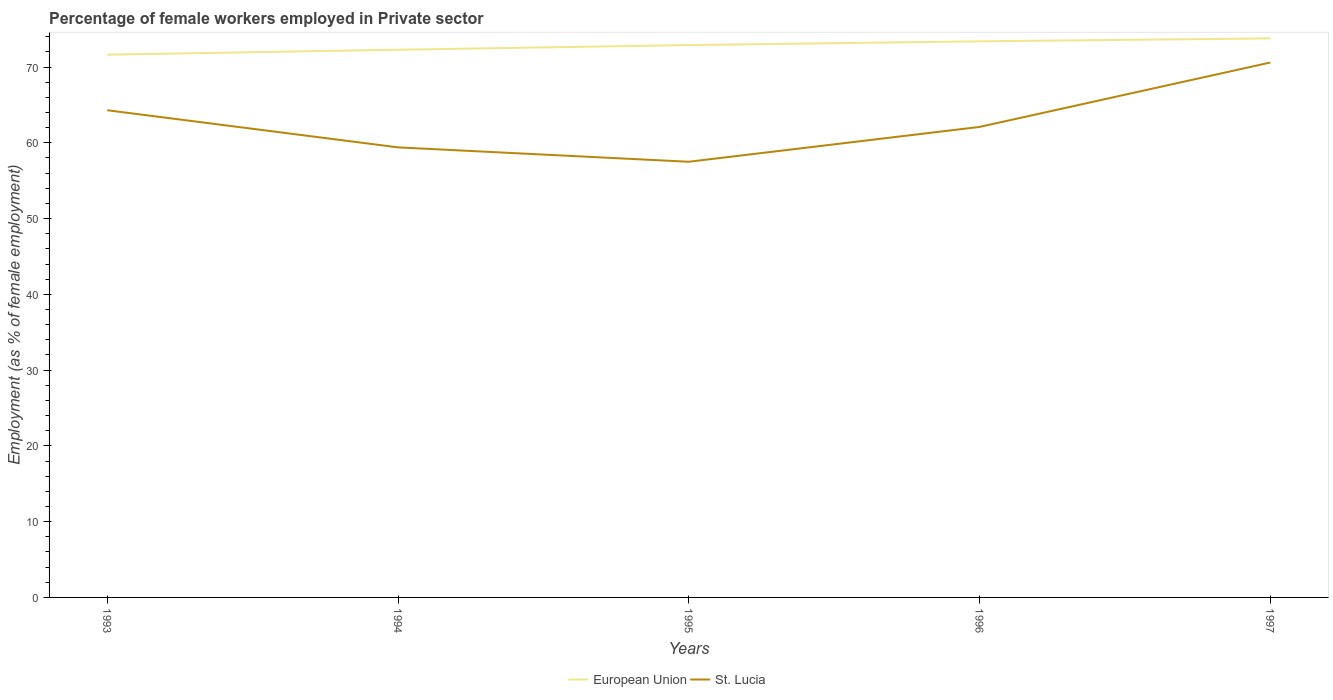Does the line corresponding to St. Lucia intersect with the line corresponding to European Union?
Your answer should be very brief. No. Is the number of lines equal to the number of legend labels?
Ensure brevity in your answer.  Yes. Across all years, what is the maximum percentage of females employed in Private sector in St. Lucia?
Offer a terse response. 57.5. In which year was the percentage of females employed in Private sector in St. Lucia maximum?
Offer a very short reply. 1995. What is the total percentage of females employed in Private sector in St. Lucia in the graph?
Ensure brevity in your answer.  -4.6. What is the difference between the highest and the second highest percentage of females employed in Private sector in St. Lucia?
Your response must be concise. 13.1. Is the percentage of females employed in Private sector in European Union strictly greater than the percentage of females employed in Private sector in St. Lucia over the years?
Provide a succinct answer. No. How many lines are there?
Ensure brevity in your answer.  2. How many years are there in the graph?
Provide a short and direct response. 5. Are the values on the major ticks of Y-axis written in scientific E-notation?
Your answer should be compact. No. Does the graph contain any zero values?
Provide a short and direct response. No. Where does the legend appear in the graph?
Provide a short and direct response. Bottom center. What is the title of the graph?
Give a very brief answer. Percentage of female workers employed in Private sector. Does "Fragile and conflict affected situations" appear as one of the legend labels in the graph?
Provide a succinct answer. No. What is the label or title of the Y-axis?
Give a very brief answer. Employment (as % of female employment). What is the Employment (as % of female employment) of European Union in 1993?
Provide a succinct answer. 71.63. What is the Employment (as % of female employment) in St. Lucia in 1993?
Give a very brief answer. 64.3. What is the Employment (as % of female employment) in European Union in 1994?
Make the answer very short. 72.29. What is the Employment (as % of female employment) of St. Lucia in 1994?
Make the answer very short. 59.4. What is the Employment (as % of female employment) of European Union in 1995?
Make the answer very short. 72.9. What is the Employment (as % of female employment) of St. Lucia in 1995?
Make the answer very short. 57.5. What is the Employment (as % of female employment) of European Union in 1996?
Keep it short and to the point. 73.4. What is the Employment (as % of female employment) of St. Lucia in 1996?
Offer a terse response. 62.1. What is the Employment (as % of female employment) of European Union in 1997?
Make the answer very short. 73.78. What is the Employment (as % of female employment) of St. Lucia in 1997?
Keep it short and to the point. 70.6. Across all years, what is the maximum Employment (as % of female employment) in European Union?
Ensure brevity in your answer.  73.78. Across all years, what is the maximum Employment (as % of female employment) in St. Lucia?
Keep it short and to the point. 70.6. Across all years, what is the minimum Employment (as % of female employment) in European Union?
Your response must be concise. 71.63. Across all years, what is the minimum Employment (as % of female employment) in St. Lucia?
Provide a succinct answer. 57.5. What is the total Employment (as % of female employment) of European Union in the graph?
Your answer should be compact. 364. What is the total Employment (as % of female employment) of St. Lucia in the graph?
Your response must be concise. 313.9. What is the difference between the Employment (as % of female employment) of European Union in 1993 and that in 1994?
Your response must be concise. -0.65. What is the difference between the Employment (as % of female employment) in St. Lucia in 1993 and that in 1994?
Ensure brevity in your answer.  4.9. What is the difference between the Employment (as % of female employment) in European Union in 1993 and that in 1995?
Offer a terse response. -1.27. What is the difference between the Employment (as % of female employment) in St. Lucia in 1993 and that in 1995?
Give a very brief answer. 6.8. What is the difference between the Employment (as % of female employment) in European Union in 1993 and that in 1996?
Give a very brief answer. -1.77. What is the difference between the Employment (as % of female employment) in European Union in 1993 and that in 1997?
Offer a very short reply. -2.15. What is the difference between the Employment (as % of female employment) of European Union in 1994 and that in 1995?
Give a very brief answer. -0.62. What is the difference between the Employment (as % of female employment) in St. Lucia in 1994 and that in 1995?
Make the answer very short. 1.9. What is the difference between the Employment (as % of female employment) of European Union in 1994 and that in 1996?
Your answer should be very brief. -1.11. What is the difference between the Employment (as % of female employment) in European Union in 1994 and that in 1997?
Offer a very short reply. -1.49. What is the difference between the Employment (as % of female employment) in St. Lucia in 1994 and that in 1997?
Offer a very short reply. -11.2. What is the difference between the Employment (as % of female employment) in European Union in 1995 and that in 1996?
Your answer should be compact. -0.5. What is the difference between the Employment (as % of female employment) in European Union in 1995 and that in 1997?
Make the answer very short. -0.88. What is the difference between the Employment (as % of female employment) in St. Lucia in 1995 and that in 1997?
Make the answer very short. -13.1. What is the difference between the Employment (as % of female employment) in European Union in 1996 and that in 1997?
Provide a succinct answer. -0.38. What is the difference between the Employment (as % of female employment) in European Union in 1993 and the Employment (as % of female employment) in St. Lucia in 1994?
Ensure brevity in your answer.  12.23. What is the difference between the Employment (as % of female employment) in European Union in 1993 and the Employment (as % of female employment) in St. Lucia in 1995?
Ensure brevity in your answer.  14.13. What is the difference between the Employment (as % of female employment) in European Union in 1993 and the Employment (as % of female employment) in St. Lucia in 1996?
Your answer should be compact. 9.53. What is the difference between the Employment (as % of female employment) in European Union in 1993 and the Employment (as % of female employment) in St. Lucia in 1997?
Provide a short and direct response. 1.03. What is the difference between the Employment (as % of female employment) of European Union in 1994 and the Employment (as % of female employment) of St. Lucia in 1995?
Ensure brevity in your answer.  14.79. What is the difference between the Employment (as % of female employment) in European Union in 1994 and the Employment (as % of female employment) in St. Lucia in 1996?
Offer a very short reply. 10.19. What is the difference between the Employment (as % of female employment) of European Union in 1994 and the Employment (as % of female employment) of St. Lucia in 1997?
Your response must be concise. 1.69. What is the difference between the Employment (as % of female employment) of European Union in 1995 and the Employment (as % of female employment) of St. Lucia in 1996?
Your answer should be compact. 10.8. What is the difference between the Employment (as % of female employment) of European Union in 1995 and the Employment (as % of female employment) of St. Lucia in 1997?
Your response must be concise. 2.3. What is the difference between the Employment (as % of female employment) in European Union in 1996 and the Employment (as % of female employment) in St. Lucia in 1997?
Your answer should be compact. 2.8. What is the average Employment (as % of female employment) of European Union per year?
Provide a short and direct response. 72.8. What is the average Employment (as % of female employment) of St. Lucia per year?
Make the answer very short. 62.78. In the year 1993, what is the difference between the Employment (as % of female employment) of European Union and Employment (as % of female employment) of St. Lucia?
Make the answer very short. 7.33. In the year 1994, what is the difference between the Employment (as % of female employment) of European Union and Employment (as % of female employment) of St. Lucia?
Provide a short and direct response. 12.89. In the year 1995, what is the difference between the Employment (as % of female employment) of European Union and Employment (as % of female employment) of St. Lucia?
Offer a very short reply. 15.4. In the year 1996, what is the difference between the Employment (as % of female employment) of European Union and Employment (as % of female employment) of St. Lucia?
Your answer should be very brief. 11.3. In the year 1997, what is the difference between the Employment (as % of female employment) in European Union and Employment (as % of female employment) in St. Lucia?
Give a very brief answer. 3.18. What is the ratio of the Employment (as % of female employment) of European Union in 1993 to that in 1994?
Provide a short and direct response. 0.99. What is the ratio of the Employment (as % of female employment) of St. Lucia in 1993 to that in 1994?
Provide a succinct answer. 1.08. What is the ratio of the Employment (as % of female employment) of European Union in 1993 to that in 1995?
Make the answer very short. 0.98. What is the ratio of the Employment (as % of female employment) in St. Lucia in 1993 to that in 1995?
Offer a terse response. 1.12. What is the ratio of the Employment (as % of female employment) of European Union in 1993 to that in 1996?
Keep it short and to the point. 0.98. What is the ratio of the Employment (as % of female employment) of St. Lucia in 1993 to that in 1996?
Your answer should be very brief. 1.04. What is the ratio of the Employment (as % of female employment) of European Union in 1993 to that in 1997?
Make the answer very short. 0.97. What is the ratio of the Employment (as % of female employment) of St. Lucia in 1993 to that in 1997?
Your answer should be very brief. 0.91. What is the ratio of the Employment (as % of female employment) in St. Lucia in 1994 to that in 1995?
Your answer should be very brief. 1.03. What is the ratio of the Employment (as % of female employment) of European Union in 1994 to that in 1996?
Offer a terse response. 0.98. What is the ratio of the Employment (as % of female employment) in St. Lucia in 1994 to that in 1996?
Provide a short and direct response. 0.96. What is the ratio of the Employment (as % of female employment) in European Union in 1994 to that in 1997?
Keep it short and to the point. 0.98. What is the ratio of the Employment (as % of female employment) of St. Lucia in 1994 to that in 1997?
Your answer should be compact. 0.84. What is the ratio of the Employment (as % of female employment) in St. Lucia in 1995 to that in 1996?
Keep it short and to the point. 0.93. What is the ratio of the Employment (as % of female employment) of St. Lucia in 1995 to that in 1997?
Provide a succinct answer. 0.81. What is the ratio of the Employment (as % of female employment) of St. Lucia in 1996 to that in 1997?
Your answer should be compact. 0.88. What is the difference between the highest and the second highest Employment (as % of female employment) of European Union?
Keep it short and to the point. 0.38. What is the difference between the highest and the second highest Employment (as % of female employment) in St. Lucia?
Provide a succinct answer. 6.3. What is the difference between the highest and the lowest Employment (as % of female employment) of European Union?
Provide a short and direct response. 2.15. What is the difference between the highest and the lowest Employment (as % of female employment) of St. Lucia?
Offer a terse response. 13.1. 